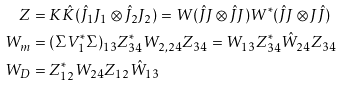Convert formula to latex. <formula><loc_0><loc_0><loc_500><loc_500>Z & = K \hat { K } ( \hat { J } _ { 1 } J _ { 1 } \otimes \hat { J } _ { 2 } J _ { 2 } ) = W ( \hat { J } J \otimes \hat { J } J ) W ^ { * } ( \hat { J } J \otimes J \hat { J } ) \\ W _ { m } & = ( \Sigma V _ { 1 } ^ { * } \Sigma ) _ { 1 3 } Z ^ { * } _ { 3 4 } W _ { 2 , 2 4 } Z _ { 3 4 } = W _ { 1 3 } Z ^ { * } _ { 3 4 } \hat { W } _ { 2 4 } Z _ { 3 4 } \\ W _ { D } & = Z _ { 1 2 } ^ { * } W _ { 2 4 } Z _ { 1 2 } \hat { W } _ { 1 3 }</formula> 